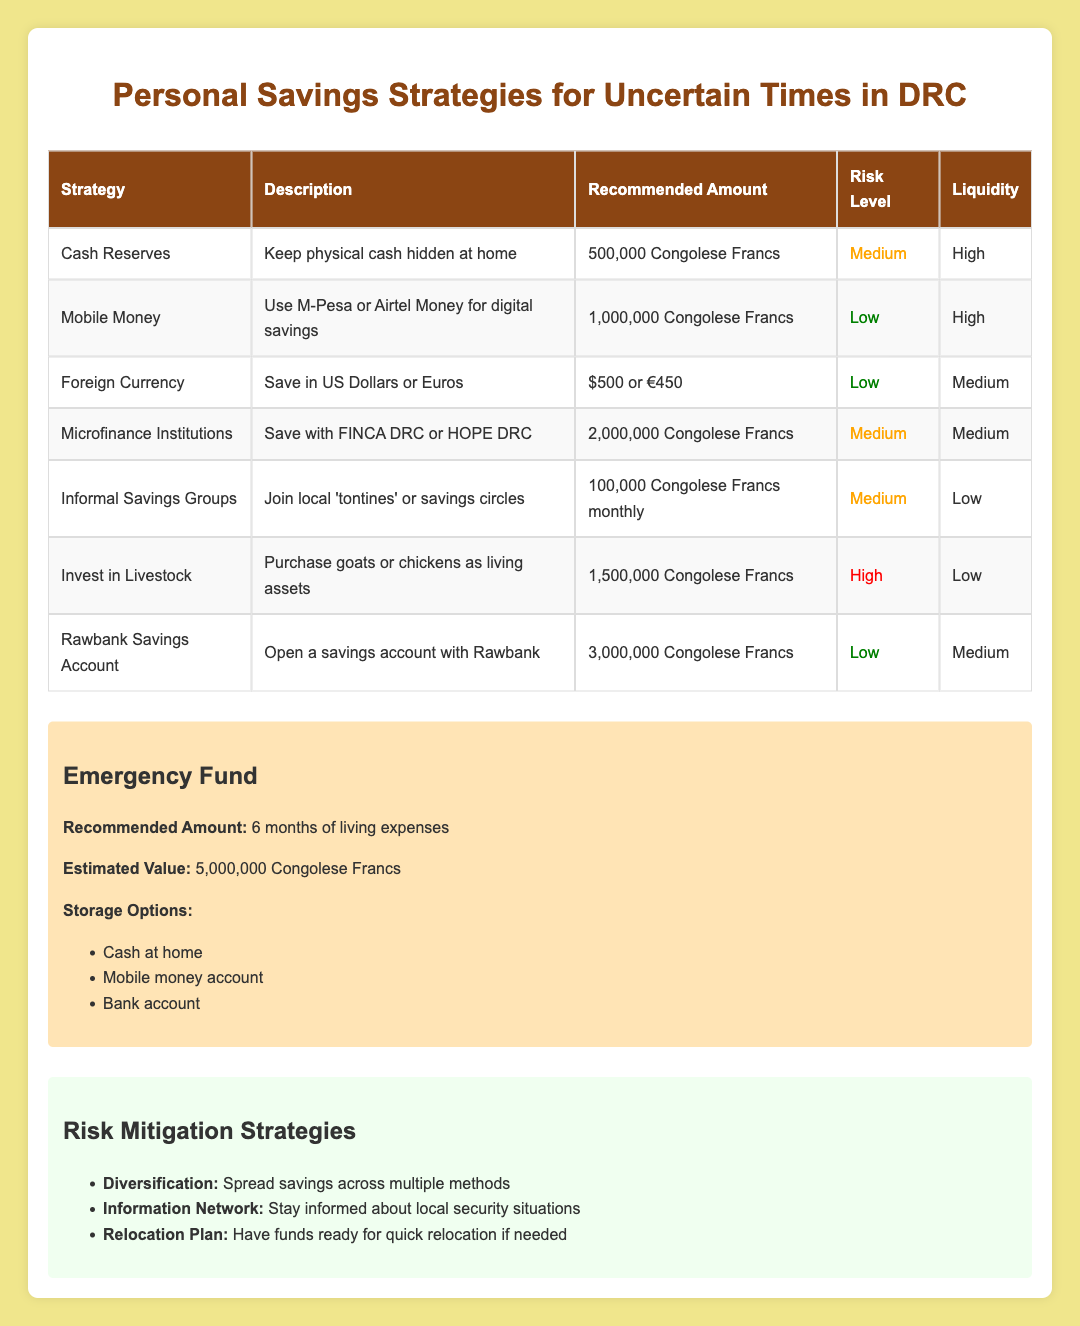What is the recommended amount for cash reserves? The table specifies that the recommended amount for cash reserves is 500,000 Congolese Francs.
Answer: 500,000 Congolese Francs Which savings strategy has the lowest risk level? According to the table, the savings strategies categorized as 'Low' risk are 'Mobile Money', 'Foreign Currency', and 'Rawbank Savings Account'. Thus, all three have the lowest risk level.
Answer: Mobile Money, Foreign Currency, Rawbank Savings Account What is the combination of recommended amounts for Mobile Money and Informal Savings Groups? The recommended amount for Mobile Money is 1,000,000 Congolese Francs and for Informal Savings Groups is 100,000 Congolese Francs monthly. The sum is 1,000,000 + 100,000 = 1,100,000 Congolese Francs.
Answer: 1,100,000 Congolese Francs Is saving in foreign currency a medium-risk strategy? The risk level for saving in foreign currency according to the table is 'Low', not 'Medium'. Thus, this statement is false.
Answer: No How many strategies listed have high liquidity? Checking the liquidity column, 'Cash Reserves', 'Mobile Money', and 'Foreign Currency' are marked as 'High' liquidity. That's a total of three strategies.
Answer: 3 What is the total recommended amount for all savings strategies? The recommended amounts for the strategies are: 500,000 (Cash Reserves) + 1,000,000 (Mobile Money) + 500 (Foreign Currency) + 2,000,000 (Microfinance Institutions) + 100,000 (Informal Savings Groups monthly) + 1,500,000 (Invest in Livestock) + 3,000,000 (Rawbank Savings Account) = 8,100,500 Congolese Francs in total.
Answer: 8,100,500 Congolese Francs Is the estimated value of the emergency fund higher than 4,000,000 Congolese Francs? The estimated value of the emergency fund is stated as 5,000,000 Congolese Francs, which is indeed higher than 4,000,000. Therefore, this statement is true.
Answer: Yes What is the recommended amount for savings with microfinance institutions? The table clearly states the recommended amount for saving with microfinance institutions as 2,000,000 Congolese Francs.
Answer: 2,000,000 Congolese Francs 